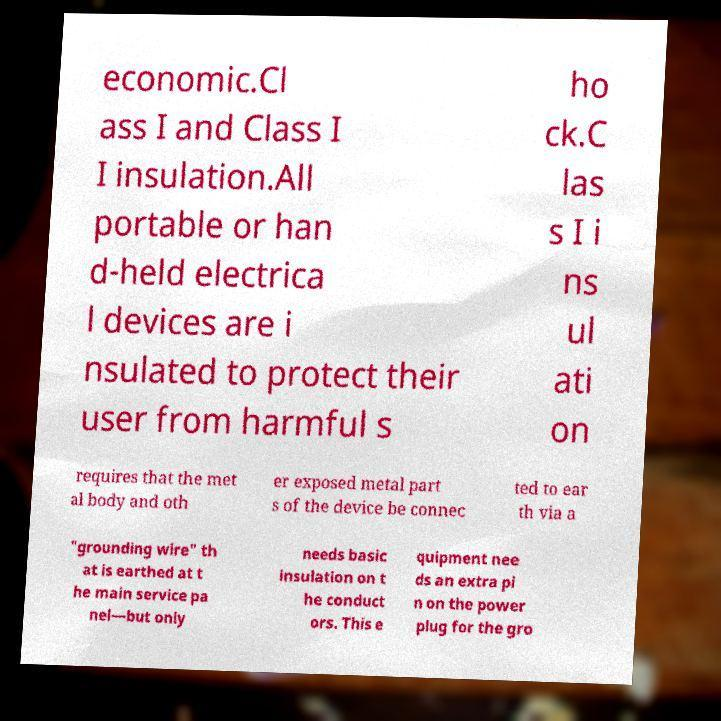Please identify and transcribe the text found in this image. economic.Cl ass I and Class I I insulation.All portable or han d-held electrica l devices are i nsulated to protect their user from harmful s ho ck.C las s I i ns ul ati on requires that the met al body and oth er exposed metal part s of the device be connec ted to ear th via a "grounding wire" th at is earthed at t he main service pa nel—but only needs basic insulation on t he conduct ors. This e quipment nee ds an extra pi n on the power plug for the gro 